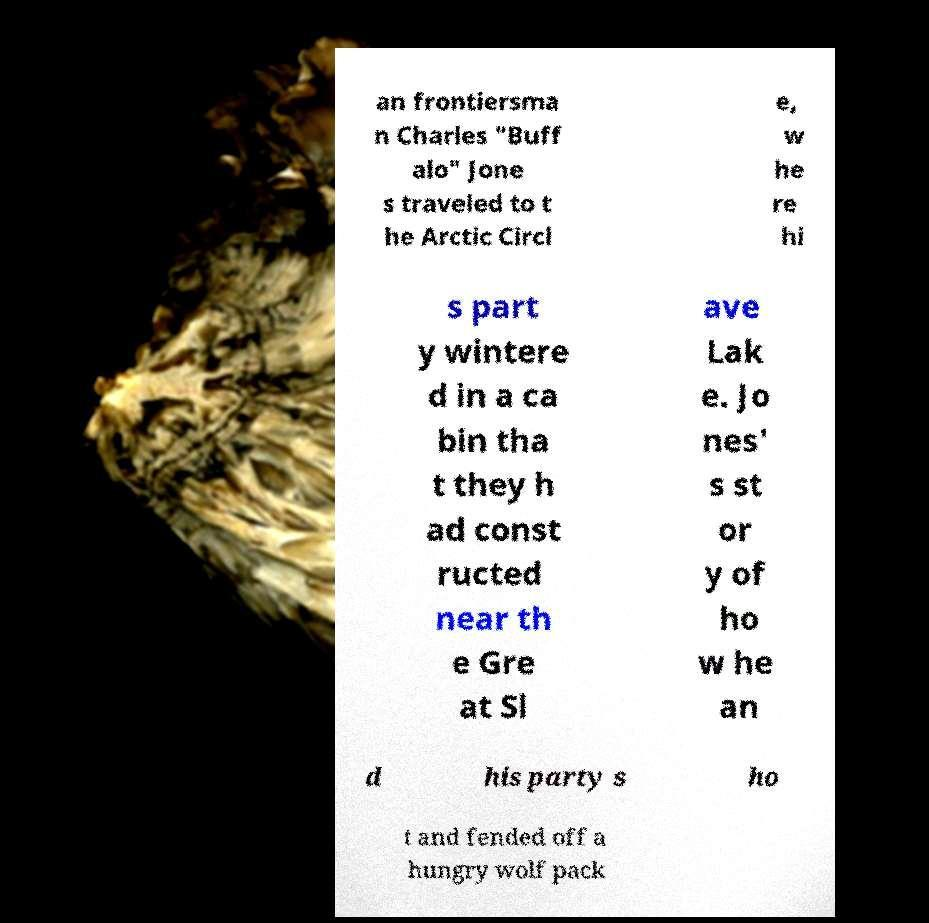What messages or text are displayed in this image? I need them in a readable, typed format. an frontiersma n Charles "Buff alo" Jone s traveled to t he Arctic Circl e, w he re hi s part y wintere d in a ca bin tha t they h ad const ructed near th e Gre at Sl ave Lak e. Jo nes' s st or y of ho w he an d his party s ho t and fended off a hungry wolf pack 